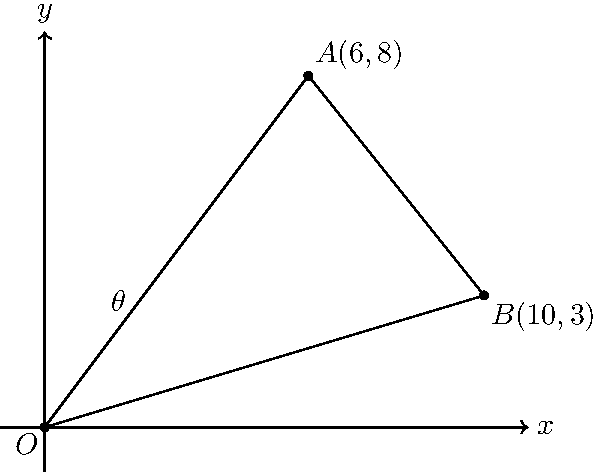Two roads intersect at the origin O(0,0) on a coordinate plane. Road A extends to point A(6,8), while road B extends to point B(10,3). Calculate the angle $\theta$ between these two roads. Given that the safe driving speed decreases by 5 mph for every 10 degrees of road angle, what is the recommended speed reduction for this intersection if the base speed limit is 55 mph? To solve this problem, we'll follow these steps:

1) First, we need to calculate the angle $\theta$ between the two roads. We can do this using the dot product formula:

   $$\cos \theta = \frac{\vec{OA} \cdot \vec{OB}}{|\vec{OA}||\vec{OB}|}$$

2) Let's calculate the vectors $\vec{OA}$ and $\vec{OB}$:
   $\vec{OA} = (6,8)$
   $\vec{OB} = (10,3)$

3) Now, let's calculate the dot product $\vec{OA} \cdot \vec{OB}$:
   $$\vec{OA} \cdot \vec{OB} = 6(10) + 8(3) = 60 + 24 = 84$$

4) Next, we need to calculate the magnitudes of the vectors:
   $$|\vec{OA}| = \sqrt{6^2 + 8^2} = \sqrt{36 + 64} = \sqrt{100} = 10$$
   $$|\vec{OB}| = \sqrt{10^2 + 3^2} = \sqrt{100 + 9} = \sqrt{109}$$

5) Now we can plug these values into our formula:
   $$\cos \theta = \frac{84}{10\sqrt{109}}$$

6) To get $\theta$, we need to take the inverse cosine (arccos) of both sides:
   $$\theta = \arccos(\frac{84}{10\sqrt{109}}) \approx 0.5859 \text{ radians}$$

7) Convert radians to degrees:
   $$\theta \approx 0.5859 \times \frac{180}{\pi} \approx 33.56°$$

8) Now, we know that the speed decreases by 5 mph for every 10 degrees. So we can set up a proportion:
   $$\frac{5 \text{ mph}}{10°} = \frac{x}{33.56°}$$

9) Solving for x:
   $$x = \frac{33.56 \times 5}{10} \approx 16.78 \text{ mph}$$

Therefore, the recommended speed reduction for this intersection is approximately 16.78 mph.
Answer: 16.78 mph 